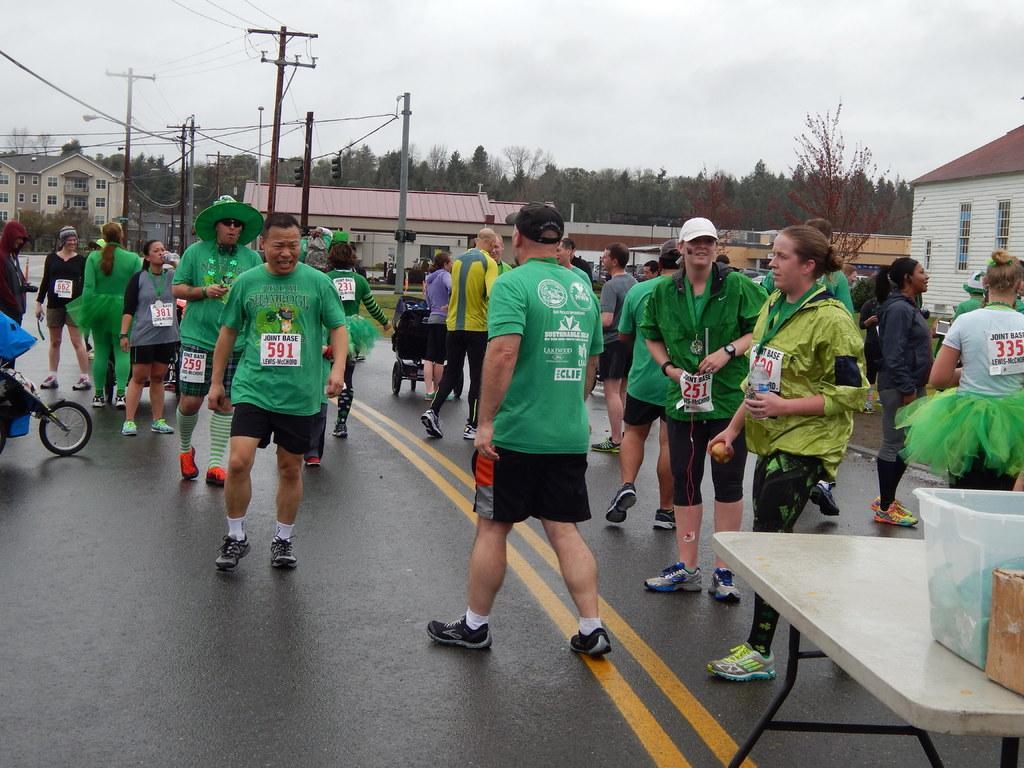In one or two sentences, can you explain what this image depicts? In this image I can see a road in the front and on it I can see number of people are standing. I can also see most of them are wearing green color dress and few of them are wearing caps. On their dresses I can see few boards and on it I can see something is written. On the right side of this image I can see a table and on it I can see a container and a box. In the background I can see number of buildings, number of trees, few poles, few wires, clouds and the sky. 